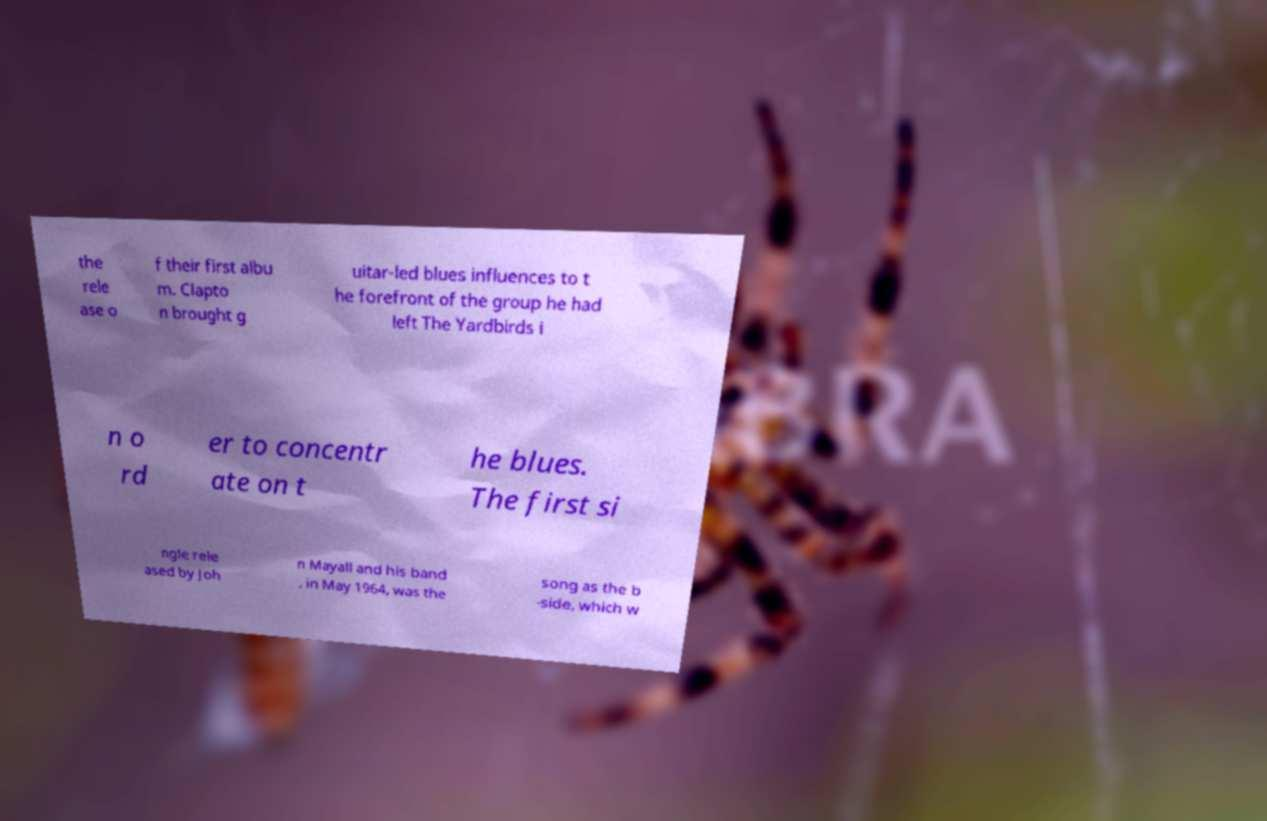Please read and relay the text visible in this image. What does it say? the rele ase o f their first albu m. Clapto n brought g uitar-led blues influences to t he forefront of the group he had left The Yardbirds i n o rd er to concentr ate on t he blues. The first si ngle rele ased by Joh n Mayall and his band , in May 1964, was the song as the b -side, which w 